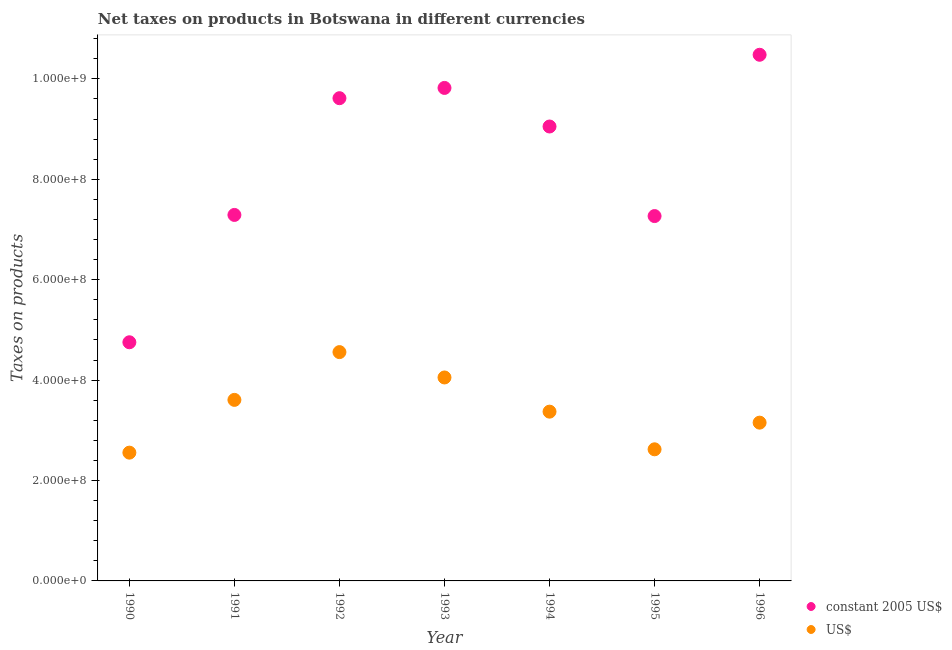What is the net taxes in us$ in 1993?
Give a very brief answer. 4.05e+08. Across all years, what is the maximum net taxes in constant 2005 us$?
Offer a terse response. 1.05e+09. Across all years, what is the minimum net taxes in us$?
Your response must be concise. 2.56e+08. In which year was the net taxes in constant 2005 us$ minimum?
Make the answer very short. 1990. What is the total net taxes in constant 2005 us$ in the graph?
Keep it short and to the point. 5.83e+09. What is the difference between the net taxes in constant 2005 us$ in 1990 and that in 1996?
Make the answer very short. -5.73e+08. What is the difference between the net taxes in constant 2005 us$ in 1993 and the net taxes in us$ in 1991?
Keep it short and to the point. 6.21e+08. What is the average net taxes in us$ per year?
Your response must be concise. 3.42e+08. In the year 1990, what is the difference between the net taxes in us$ and net taxes in constant 2005 us$?
Make the answer very short. -2.20e+08. What is the ratio of the net taxes in us$ in 1991 to that in 1995?
Offer a terse response. 1.38. What is the difference between the highest and the second highest net taxes in constant 2005 us$?
Offer a terse response. 6.60e+07. What is the difference between the highest and the lowest net taxes in constant 2005 us$?
Your answer should be very brief. 5.73e+08. Does the net taxes in constant 2005 us$ monotonically increase over the years?
Provide a short and direct response. No. Is the net taxes in us$ strictly less than the net taxes in constant 2005 us$ over the years?
Ensure brevity in your answer.  Yes. How many years are there in the graph?
Make the answer very short. 7. What is the difference between two consecutive major ticks on the Y-axis?
Your answer should be very brief. 2.00e+08. Are the values on the major ticks of Y-axis written in scientific E-notation?
Offer a very short reply. Yes. Does the graph contain any zero values?
Your answer should be very brief. No. Does the graph contain grids?
Your answer should be compact. No. Where does the legend appear in the graph?
Offer a terse response. Bottom right. How many legend labels are there?
Give a very brief answer. 2. How are the legend labels stacked?
Your answer should be very brief. Vertical. What is the title of the graph?
Give a very brief answer. Net taxes on products in Botswana in different currencies. Does "Adolescent fertility rate" appear as one of the legend labels in the graph?
Provide a succinct answer. No. What is the label or title of the Y-axis?
Ensure brevity in your answer.  Taxes on products. What is the Taxes on products of constant 2005 US$ in 1990?
Your answer should be very brief. 4.75e+08. What is the Taxes on products in US$ in 1990?
Provide a succinct answer. 2.56e+08. What is the Taxes on products in constant 2005 US$ in 1991?
Provide a succinct answer. 7.29e+08. What is the Taxes on products in US$ in 1991?
Provide a succinct answer. 3.61e+08. What is the Taxes on products of constant 2005 US$ in 1992?
Offer a terse response. 9.62e+08. What is the Taxes on products of US$ in 1992?
Your response must be concise. 4.56e+08. What is the Taxes on products of constant 2005 US$ in 1993?
Give a very brief answer. 9.82e+08. What is the Taxes on products in US$ in 1993?
Offer a terse response. 4.05e+08. What is the Taxes on products of constant 2005 US$ in 1994?
Your answer should be compact. 9.05e+08. What is the Taxes on products in US$ in 1994?
Provide a succinct answer. 3.37e+08. What is the Taxes on products of constant 2005 US$ in 1995?
Your response must be concise. 7.27e+08. What is the Taxes on products in US$ in 1995?
Keep it short and to the point. 2.62e+08. What is the Taxes on products of constant 2005 US$ in 1996?
Your response must be concise. 1.05e+09. What is the Taxes on products of US$ in 1996?
Your answer should be very brief. 3.15e+08. Across all years, what is the maximum Taxes on products in constant 2005 US$?
Make the answer very short. 1.05e+09. Across all years, what is the maximum Taxes on products of US$?
Your response must be concise. 4.56e+08. Across all years, what is the minimum Taxes on products in constant 2005 US$?
Your answer should be very brief. 4.75e+08. Across all years, what is the minimum Taxes on products of US$?
Ensure brevity in your answer.  2.56e+08. What is the total Taxes on products in constant 2005 US$ in the graph?
Keep it short and to the point. 5.83e+09. What is the total Taxes on products in US$ in the graph?
Offer a terse response. 2.39e+09. What is the difference between the Taxes on products of constant 2005 US$ in 1990 and that in 1991?
Make the answer very short. -2.54e+08. What is the difference between the Taxes on products of US$ in 1990 and that in 1991?
Provide a succinct answer. -1.05e+08. What is the difference between the Taxes on products of constant 2005 US$ in 1990 and that in 1992?
Offer a terse response. -4.86e+08. What is the difference between the Taxes on products of US$ in 1990 and that in 1992?
Offer a terse response. -2.00e+08. What is the difference between the Taxes on products in constant 2005 US$ in 1990 and that in 1993?
Offer a terse response. -5.07e+08. What is the difference between the Taxes on products of US$ in 1990 and that in 1993?
Offer a very short reply. -1.50e+08. What is the difference between the Taxes on products in constant 2005 US$ in 1990 and that in 1994?
Give a very brief answer. -4.30e+08. What is the difference between the Taxes on products in US$ in 1990 and that in 1994?
Your answer should be very brief. -8.17e+07. What is the difference between the Taxes on products in constant 2005 US$ in 1990 and that in 1995?
Your answer should be compact. -2.51e+08. What is the difference between the Taxes on products of US$ in 1990 and that in 1995?
Offer a very short reply. -6.65e+06. What is the difference between the Taxes on products of constant 2005 US$ in 1990 and that in 1996?
Provide a succinct answer. -5.73e+08. What is the difference between the Taxes on products in US$ in 1990 and that in 1996?
Your answer should be compact. -5.98e+07. What is the difference between the Taxes on products in constant 2005 US$ in 1991 and that in 1992?
Offer a terse response. -2.33e+08. What is the difference between the Taxes on products of US$ in 1991 and that in 1992?
Offer a terse response. -9.52e+07. What is the difference between the Taxes on products of constant 2005 US$ in 1991 and that in 1993?
Give a very brief answer. -2.53e+08. What is the difference between the Taxes on products of US$ in 1991 and that in 1993?
Provide a succinct answer. -4.47e+07. What is the difference between the Taxes on products in constant 2005 US$ in 1991 and that in 1994?
Provide a succinct answer. -1.76e+08. What is the difference between the Taxes on products in US$ in 1991 and that in 1994?
Keep it short and to the point. 2.34e+07. What is the difference between the Taxes on products of constant 2005 US$ in 1991 and that in 1995?
Make the answer very short. 2.25e+06. What is the difference between the Taxes on products of US$ in 1991 and that in 1995?
Your answer should be very brief. 9.85e+07. What is the difference between the Taxes on products of constant 2005 US$ in 1991 and that in 1996?
Keep it short and to the point. -3.19e+08. What is the difference between the Taxes on products in US$ in 1991 and that in 1996?
Provide a short and direct response. 4.53e+07. What is the difference between the Taxes on products of constant 2005 US$ in 1992 and that in 1993?
Ensure brevity in your answer.  -2.05e+07. What is the difference between the Taxes on products of US$ in 1992 and that in 1993?
Offer a very short reply. 5.05e+07. What is the difference between the Taxes on products of constant 2005 US$ in 1992 and that in 1994?
Keep it short and to the point. 5.64e+07. What is the difference between the Taxes on products of US$ in 1992 and that in 1994?
Your answer should be very brief. 1.19e+08. What is the difference between the Taxes on products of constant 2005 US$ in 1992 and that in 1995?
Offer a terse response. 2.35e+08. What is the difference between the Taxes on products of US$ in 1992 and that in 1995?
Make the answer very short. 1.94e+08. What is the difference between the Taxes on products of constant 2005 US$ in 1992 and that in 1996?
Offer a terse response. -8.65e+07. What is the difference between the Taxes on products in US$ in 1992 and that in 1996?
Your answer should be very brief. 1.41e+08. What is the difference between the Taxes on products of constant 2005 US$ in 1993 and that in 1994?
Your answer should be very brief. 7.69e+07. What is the difference between the Taxes on products of US$ in 1993 and that in 1994?
Keep it short and to the point. 6.81e+07. What is the difference between the Taxes on products in constant 2005 US$ in 1993 and that in 1995?
Your answer should be compact. 2.55e+08. What is the difference between the Taxes on products in US$ in 1993 and that in 1995?
Make the answer very short. 1.43e+08. What is the difference between the Taxes on products of constant 2005 US$ in 1993 and that in 1996?
Offer a terse response. -6.60e+07. What is the difference between the Taxes on products of US$ in 1993 and that in 1996?
Your response must be concise. 9.00e+07. What is the difference between the Taxes on products of constant 2005 US$ in 1994 and that in 1995?
Offer a terse response. 1.78e+08. What is the difference between the Taxes on products in US$ in 1994 and that in 1995?
Your response must be concise. 7.50e+07. What is the difference between the Taxes on products in constant 2005 US$ in 1994 and that in 1996?
Your answer should be very brief. -1.43e+08. What is the difference between the Taxes on products in US$ in 1994 and that in 1996?
Provide a short and direct response. 2.19e+07. What is the difference between the Taxes on products of constant 2005 US$ in 1995 and that in 1996?
Offer a very short reply. -3.21e+08. What is the difference between the Taxes on products in US$ in 1995 and that in 1996?
Keep it short and to the point. -5.31e+07. What is the difference between the Taxes on products in constant 2005 US$ in 1990 and the Taxes on products in US$ in 1991?
Provide a succinct answer. 1.15e+08. What is the difference between the Taxes on products in constant 2005 US$ in 1990 and the Taxes on products in US$ in 1992?
Provide a succinct answer. 1.96e+07. What is the difference between the Taxes on products in constant 2005 US$ in 1990 and the Taxes on products in US$ in 1993?
Keep it short and to the point. 7.01e+07. What is the difference between the Taxes on products in constant 2005 US$ in 1990 and the Taxes on products in US$ in 1994?
Make the answer very short. 1.38e+08. What is the difference between the Taxes on products in constant 2005 US$ in 1990 and the Taxes on products in US$ in 1995?
Keep it short and to the point. 2.13e+08. What is the difference between the Taxes on products of constant 2005 US$ in 1990 and the Taxes on products of US$ in 1996?
Your answer should be compact. 1.60e+08. What is the difference between the Taxes on products of constant 2005 US$ in 1991 and the Taxes on products of US$ in 1992?
Keep it short and to the point. 2.73e+08. What is the difference between the Taxes on products in constant 2005 US$ in 1991 and the Taxes on products in US$ in 1993?
Give a very brief answer. 3.24e+08. What is the difference between the Taxes on products of constant 2005 US$ in 1991 and the Taxes on products of US$ in 1994?
Your answer should be compact. 3.92e+08. What is the difference between the Taxes on products of constant 2005 US$ in 1991 and the Taxes on products of US$ in 1995?
Provide a succinct answer. 4.67e+08. What is the difference between the Taxes on products of constant 2005 US$ in 1991 and the Taxes on products of US$ in 1996?
Your response must be concise. 4.14e+08. What is the difference between the Taxes on products in constant 2005 US$ in 1992 and the Taxes on products in US$ in 1993?
Your answer should be very brief. 5.56e+08. What is the difference between the Taxes on products in constant 2005 US$ in 1992 and the Taxes on products in US$ in 1994?
Your answer should be compact. 6.24e+08. What is the difference between the Taxes on products of constant 2005 US$ in 1992 and the Taxes on products of US$ in 1995?
Offer a very short reply. 6.99e+08. What is the difference between the Taxes on products of constant 2005 US$ in 1992 and the Taxes on products of US$ in 1996?
Your answer should be very brief. 6.46e+08. What is the difference between the Taxes on products in constant 2005 US$ in 1993 and the Taxes on products in US$ in 1994?
Keep it short and to the point. 6.45e+08. What is the difference between the Taxes on products of constant 2005 US$ in 1993 and the Taxes on products of US$ in 1995?
Your answer should be compact. 7.20e+08. What is the difference between the Taxes on products of constant 2005 US$ in 1993 and the Taxes on products of US$ in 1996?
Provide a short and direct response. 6.67e+08. What is the difference between the Taxes on products of constant 2005 US$ in 1994 and the Taxes on products of US$ in 1995?
Give a very brief answer. 6.43e+08. What is the difference between the Taxes on products in constant 2005 US$ in 1994 and the Taxes on products in US$ in 1996?
Offer a very short reply. 5.90e+08. What is the difference between the Taxes on products in constant 2005 US$ in 1995 and the Taxes on products in US$ in 1996?
Keep it short and to the point. 4.12e+08. What is the average Taxes on products in constant 2005 US$ per year?
Provide a short and direct response. 8.33e+08. What is the average Taxes on products in US$ per year?
Ensure brevity in your answer.  3.42e+08. In the year 1990, what is the difference between the Taxes on products in constant 2005 US$ and Taxes on products in US$?
Offer a terse response. 2.20e+08. In the year 1991, what is the difference between the Taxes on products in constant 2005 US$ and Taxes on products in US$?
Offer a very short reply. 3.68e+08. In the year 1992, what is the difference between the Taxes on products in constant 2005 US$ and Taxes on products in US$?
Provide a short and direct response. 5.06e+08. In the year 1993, what is the difference between the Taxes on products in constant 2005 US$ and Taxes on products in US$?
Offer a very short reply. 5.77e+08. In the year 1994, what is the difference between the Taxes on products in constant 2005 US$ and Taxes on products in US$?
Keep it short and to the point. 5.68e+08. In the year 1995, what is the difference between the Taxes on products in constant 2005 US$ and Taxes on products in US$?
Provide a succinct answer. 4.65e+08. In the year 1996, what is the difference between the Taxes on products of constant 2005 US$ and Taxes on products of US$?
Make the answer very short. 7.33e+08. What is the ratio of the Taxes on products of constant 2005 US$ in 1990 to that in 1991?
Offer a very short reply. 0.65. What is the ratio of the Taxes on products in US$ in 1990 to that in 1991?
Your answer should be very brief. 0.71. What is the ratio of the Taxes on products in constant 2005 US$ in 1990 to that in 1992?
Offer a terse response. 0.49. What is the ratio of the Taxes on products of US$ in 1990 to that in 1992?
Offer a terse response. 0.56. What is the ratio of the Taxes on products in constant 2005 US$ in 1990 to that in 1993?
Provide a short and direct response. 0.48. What is the ratio of the Taxes on products in US$ in 1990 to that in 1993?
Your response must be concise. 0.63. What is the ratio of the Taxes on products in constant 2005 US$ in 1990 to that in 1994?
Provide a succinct answer. 0.53. What is the ratio of the Taxes on products of US$ in 1990 to that in 1994?
Offer a terse response. 0.76. What is the ratio of the Taxes on products of constant 2005 US$ in 1990 to that in 1995?
Offer a terse response. 0.65. What is the ratio of the Taxes on products in US$ in 1990 to that in 1995?
Provide a succinct answer. 0.97. What is the ratio of the Taxes on products in constant 2005 US$ in 1990 to that in 1996?
Provide a succinct answer. 0.45. What is the ratio of the Taxes on products in US$ in 1990 to that in 1996?
Make the answer very short. 0.81. What is the ratio of the Taxes on products in constant 2005 US$ in 1991 to that in 1992?
Offer a terse response. 0.76. What is the ratio of the Taxes on products in US$ in 1991 to that in 1992?
Provide a succinct answer. 0.79. What is the ratio of the Taxes on products of constant 2005 US$ in 1991 to that in 1993?
Make the answer very short. 0.74. What is the ratio of the Taxes on products of US$ in 1991 to that in 1993?
Make the answer very short. 0.89. What is the ratio of the Taxes on products of constant 2005 US$ in 1991 to that in 1994?
Your answer should be very brief. 0.81. What is the ratio of the Taxes on products in US$ in 1991 to that in 1994?
Your response must be concise. 1.07. What is the ratio of the Taxes on products in US$ in 1991 to that in 1995?
Your answer should be compact. 1.38. What is the ratio of the Taxes on products in constant 2005 US$ in 1991 to that in 1996?
Provide a succinct answer. 0.7. What is the ratio of the Taxes on products in US$ in 1991 to that in 1996?
Provide a short and direct response. 1.14. What is the ratio of the Taxes on products of constant 2005 US$ in 1992 to that in 1993?
Your response must be concise. 0.98. What is the ratio of the Taxes on products in US$ in 1992 to that in 1993?
Your response must be concise. 1.12. What is the ratio of the Taxes on products in constant 2005 US$ in 1992 to that in 1994?
Offer a terse response. 1.06. What is the ratio of the Taxes on products in US$ in 1992 to that in 1994?
Offer a very short reply. 1.35. What is the ratio of the Taxes on products of constant 2005 US$ in 1992 to that in 1995?
Offer a very short reply. 1.32. What is the ratio of the Taxes on products in US$ in 1992 to that in 1995?
Provide a short and direct response. 1.74. What is the ratio of the Taxes on products in constant 2005 US$ in 1992 to that in 1996?
Your response must be concise. 0.92. What is the ratio of the Taxes on products of US$ in 1992 to that in 1996?
Make the answer very short. 1.45. What is the ratio of the Taxes on products in constant 2005 US$ in 1993 to that in 1994?
Your response must be concise. 1.08. What is the ratio of the Taxes on products of US$ in 1993 to that in 1994?
Ensure brevity in your answer.  1.2. What is the ratio of the Taxes on products in constant 2005 US$ in 1993 to that in 1995?
Provide a short and direct response. 1.35. What is the ratio of the Taxes on products in US$ in 1993 to that in 1995?
Provide a succinct answer. 1.55. What is the ratio of the Taxes on products in constant 2005 US$ in 1993 to that in 1996?
Provide a short and direct response. 0.94. What is the ratio of the Taxes on products in US$ in 1993 to that in 1996?
Give a very brief answer. 1.29. What is the ratio of the Taxes on products in constant 2005 US$ in 1994 to that in 1995?
Your answer should be compact. 1.25. What is the ratio of the Taxes on products of US$ in 1994 to that in 1995?
Your answer should be compact. 1.29. What is the ratio of the Taxes on products in constant 2005 US$ in 1994 to that in 1996?
Your answer should be compact. 0.86. What is the ratio of the Taxes on products in US$ in 1994 to that in 1996?
Provide a succinct answer. 1.07. What is the ratio of the Taxes on products in constant 2005 US$ in 1995 to that in 1996?
Keep it short and to the point. 0.69. What is the ratio of the Taxes on products of US$ in 1995 to that in 1996?
Ensure brevity in your answer.  0.83. What is the difference between the highest and the second highest Taxes on products in constant 2005 US$?
Your response must be concise. 6.60e+07. What is the difference between the highest and the second highest Taxes on products of US$?
Keep it short and to the point. 5.05e+07. What is the difference between the highest and the lowest Taxes on products in constant 2005 US$?
Your answer should be compact. 5.73e+08. What is the difference between the highest and the lowest Taxes on products in US$?
Your response must be concise. 2.00e+08. 